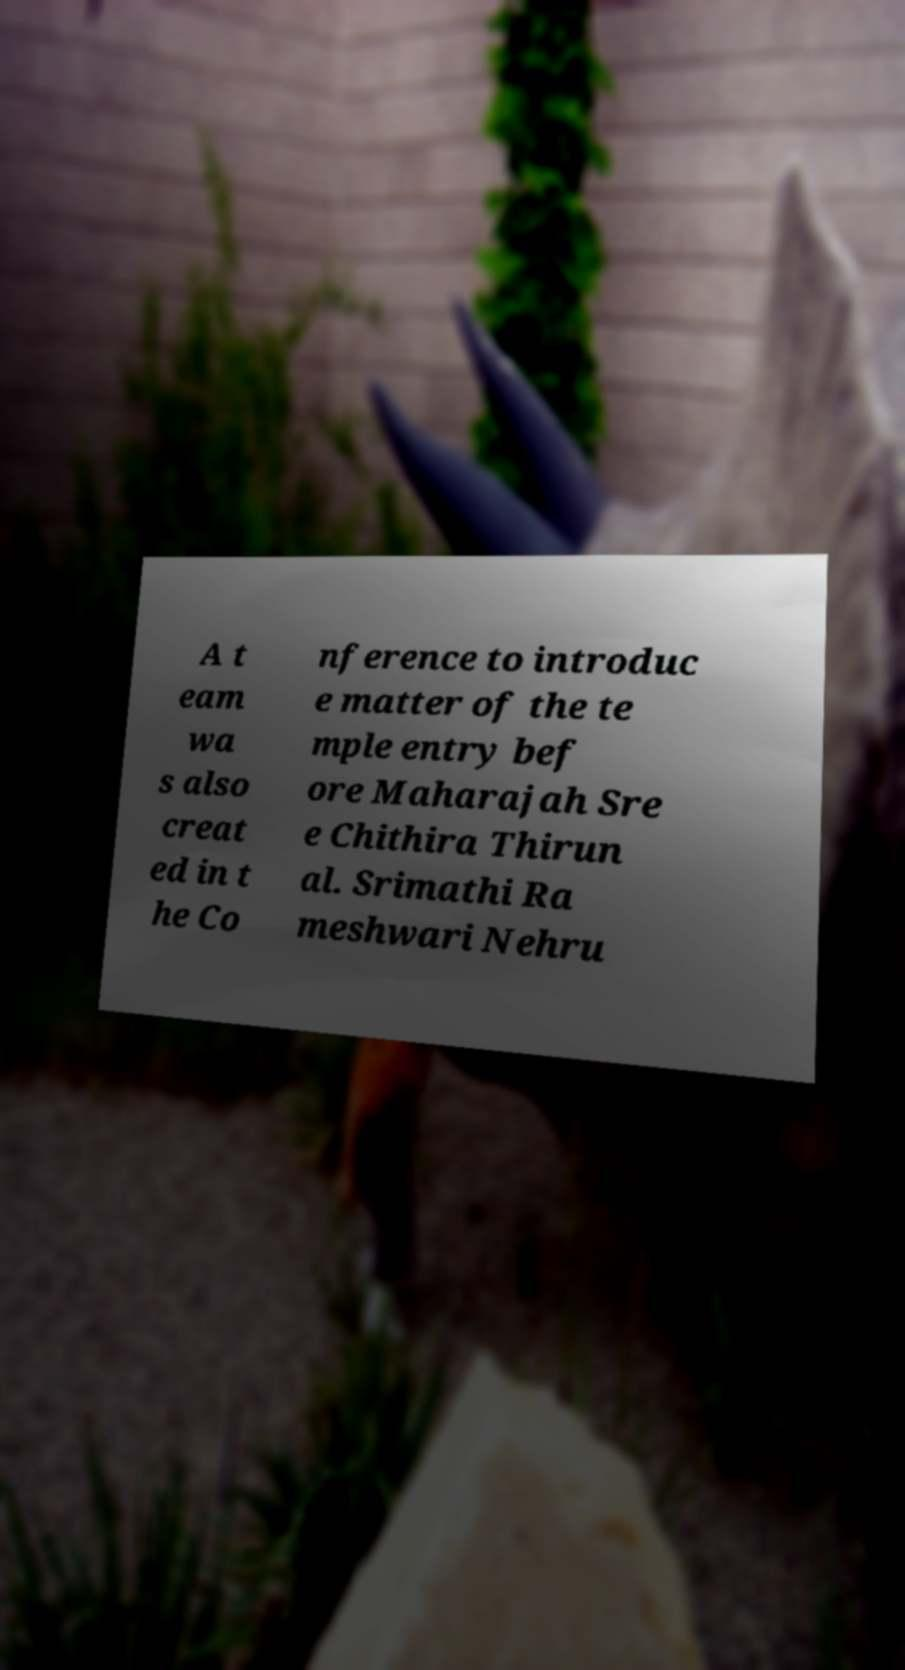For documentation purposes, I need the text within this image transcribed. Could you provide that? A t eam wa s also creat ed in t he Co nference to introduc e matter of the te mple entry bef ore Maharajah Sre e Chithira Thirun al. Srimathi Ra meshwari Nehru 